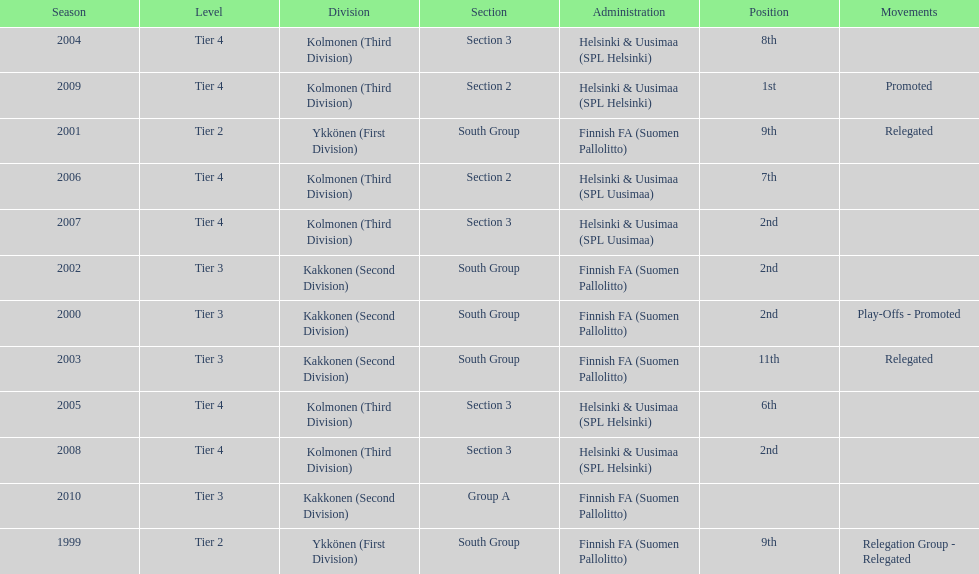How many times has this team been relegated? 3. 